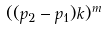<formula> <loc_0><loc_0><loc_500><loc_500>( ( p _ { 2 } - p _ { 1 } ) k ) ^ { m }</formula> 